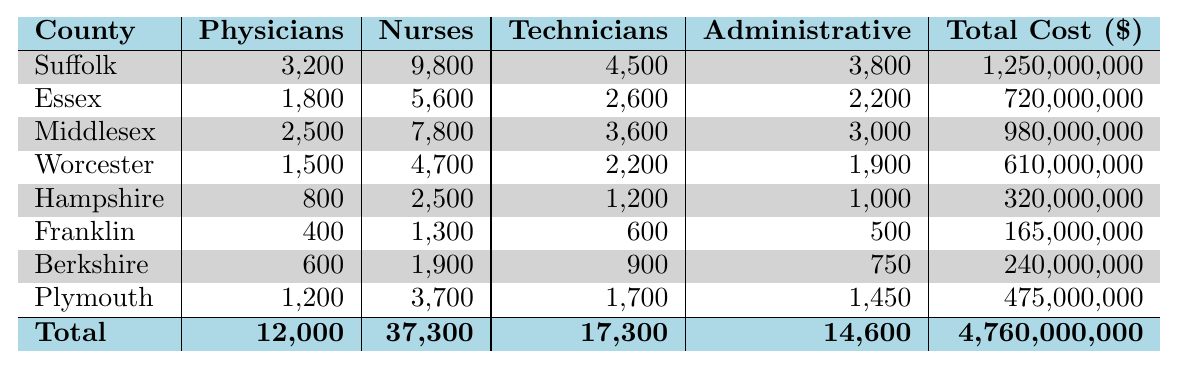What is the total number of Physicians across all counties? By adding the number of Physicians in each county: 3200 (Suffolk) + 1800 (Essex) + 2500 (Middlesex) + 1500 (Worcester) + 800 (Hampshire) + 400 (Franklin) + 600 (Berkshire) + 1200 (Plymouth) = 12000.
Answer: 12000 Which county has the highest total cost for healthcare workforce? Looking at the total costs listed for each county, Suffolk has the highest total cost at 1,250,000,000.
Answer: Suffolk What is the average number of Nurses per county? We sum the number of Nurses from each county: 9800 (Suffolk) + 5600 (Essex) + 7800 (Middlesex) + 4700 (Worcester) + 2500 (Hampshire) + 1300 (Franklin) + 1900 (Berkshire) + 3700 (Plymouth) = 37300. Then divide by the number of counties (8): 37300 / 8 = 4662.5.
Answer: 4662.5 Is the total number of Technicians greater than the total number of Administrative staff across all counties? First, sum the Technicians: 4500 (Suffolk) + 2600 (Essex) + 3600 (Middlesex) + 2200 (Worcester) + 1200 (Hampshire) + 600 (Franklin) + 900 (Berkshire) + 1700 (Plymouth) = 17300. Then sum the Administrative staff: 3800 (Suffolk) + 2200 (Essex) + 3000 (Middlesex) + 1900 (Worcester) + 1000 (Hampshire) + 500 (Franklin) + 750 (Berkshire) + 1450 (Plymouth) = 14600. Since 17300 > 14600, the statement is true.
Answer: Yes Which county has the lowest number of Nurses, and how many are there? By examining the Nurses' data, Franklin has the lowest number at 1300.
Answer: Franklin, 1300 If we combine the total cost of Hampshire and Franklin, how does it compare to the total cost of Suffolk? First, sum the costs: Hampshire is 320,000,000 and Franklin is 165,000,000. So, 320,000,000 + 165,000,000 = 485,000,000. Now compare this with Suffolk's cost of 1,250,000,000. Since 485,000,000 < 1,250,000,000, Hampshire and Franklin combined costs less than Suffolk's cost.
Answer: Less than Suffolk What fraction of total workforce does Physicians represent across all counties? The total workforce is 12000 (Physicians) + 37300 (Nurses) + 17300 (Technicians) + 14600 (Administrative) = 76000. The fraction of Physicians is 12000 / 76000 = 0.1579. Thus, approximately 15.79%.
Answer: 15.79% How many more Nurses than Technicians are there in Middlesex? In Middlesex, the number of Nurses is 7800 and the number of Technicians is 3600. The difference is calculated as 7800 - 3600 = 4200.
Answer: 4200 